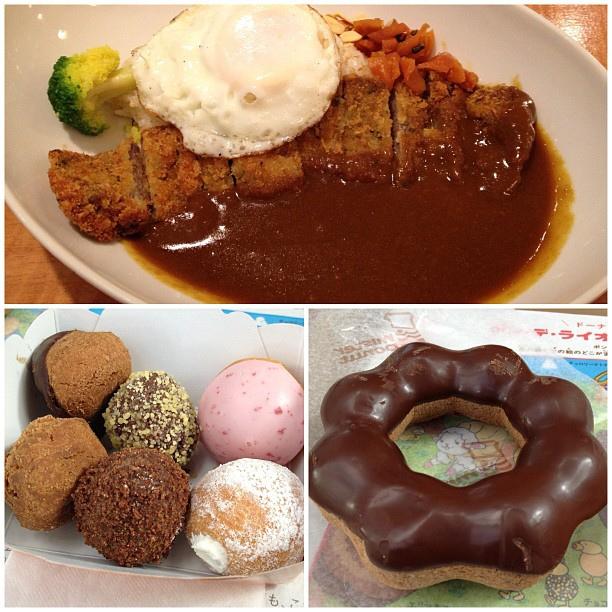What is the main prominent color of the objects?
Concise answer only. Brown. Are these all typical desserts?
Answer briefly. No. IS there mashed potatoes  here?
Give a very brief answer. No. 